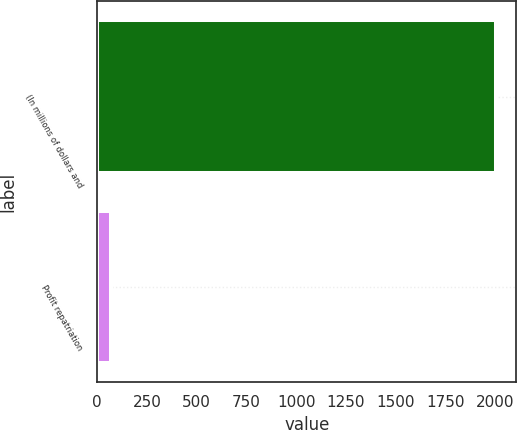<chart> <loc_0><loc_0><loc_500><loc_500><bar_chart><fcel>(In millions of dollars and<fcel>Profit repatriation<nl><fcel>2007<fcel>67.8<nl></chart> 